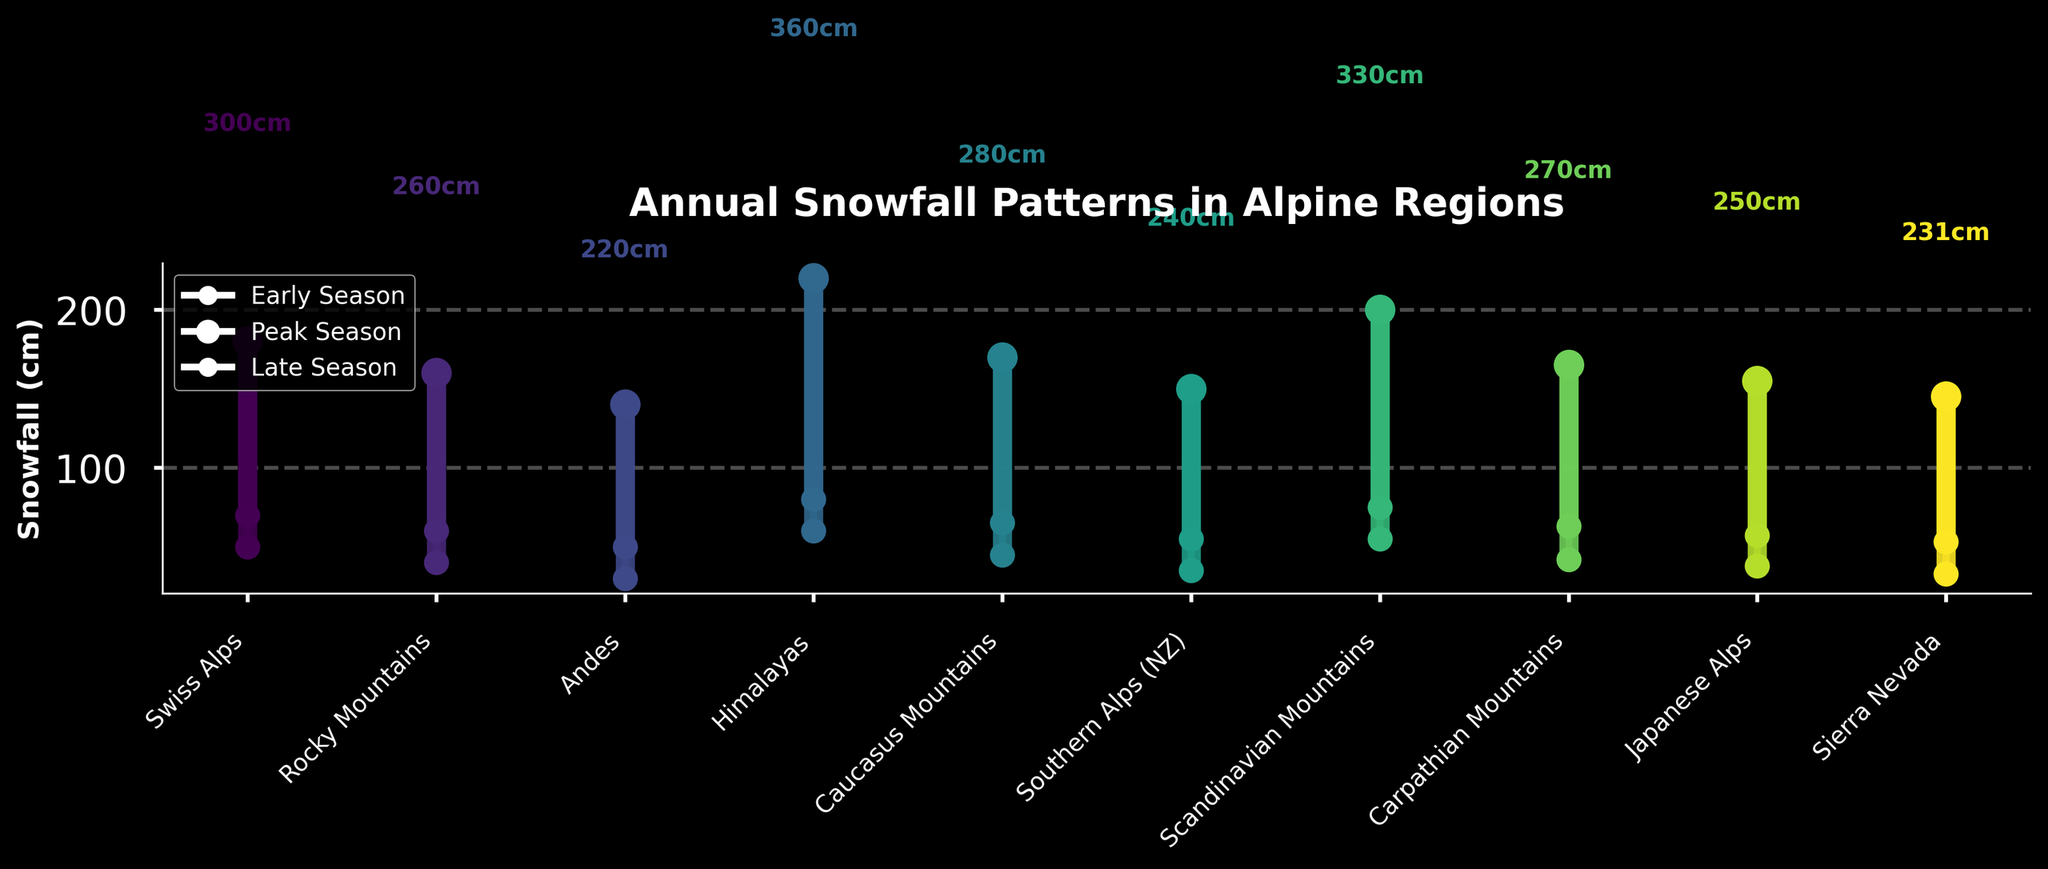Which alpine region has the highest peak season snowfall? The vertical bar representing peak season snowfall for the Himalayas is the tallest among all regions.
Answer: Himalayas What is the annual total snowfall in the Scandinavian Mountains? By examining the annotations above the bars, the annual total snowfall for the Scandinavian Mountains is labeled.
Answer: 330 cm How does the early season snowfall in the Swiss Alps compare to the Sierra Nevada? Compare the early season snowfall markers (smaller circles) of the Swiss Alps and Sierra Nevada. The Swiss Alps have a higher position.
Answer: Swiss Alps have more What is the difference in peak season snowfall between the Andes and the Carpathian Mountains? Subtract the peak season snowfall value of the Andes (140 cm) from that of the Carpathian Mountains (165 cm).
Answer: 25 cm Which region has the smallest late season snowfall? The region with the smallest late season marker (smallest circle) positioned lowest on the y-axis is the Andes.
Answer: Andes What is the total snowfall for the Rocky Mountains? Look at the annotation above the bar for the Rocky Mountains.
Answer: 260 cm Which region has the second highest annual snowfall total? By comparing the annotated total snowfall amounts, the Scandinavian Mountains have the second highest total snowfall.
Answer: Scandinavian Mountains How does the clarity of snowfall patterns between early and late seasons differ across the regions? The OHLC bars show that early season snowfall (bottom marker) and late season snowfall (top marker) variability across regions is represented by the z-order and scatter positions. More crowded lower and higher positions across different regions show mixed patterns.
Answer: Mixed patterns Considering the peak season snowfall, which region ranks second to last? By visually comparing the heights of the peak season markers (middle circles with larger size), the Southern Alps have the second to last height.
Answer: Southern Alps 